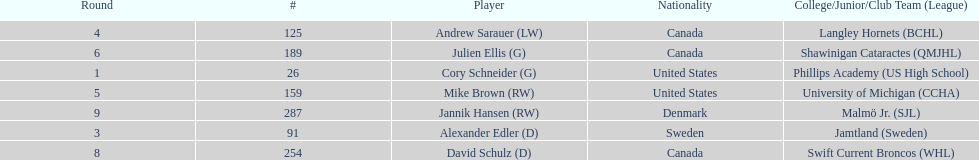List each player drafted from canada. Andrew Sarauer (LW), Julien Ellis (G), David Schulz (D). 